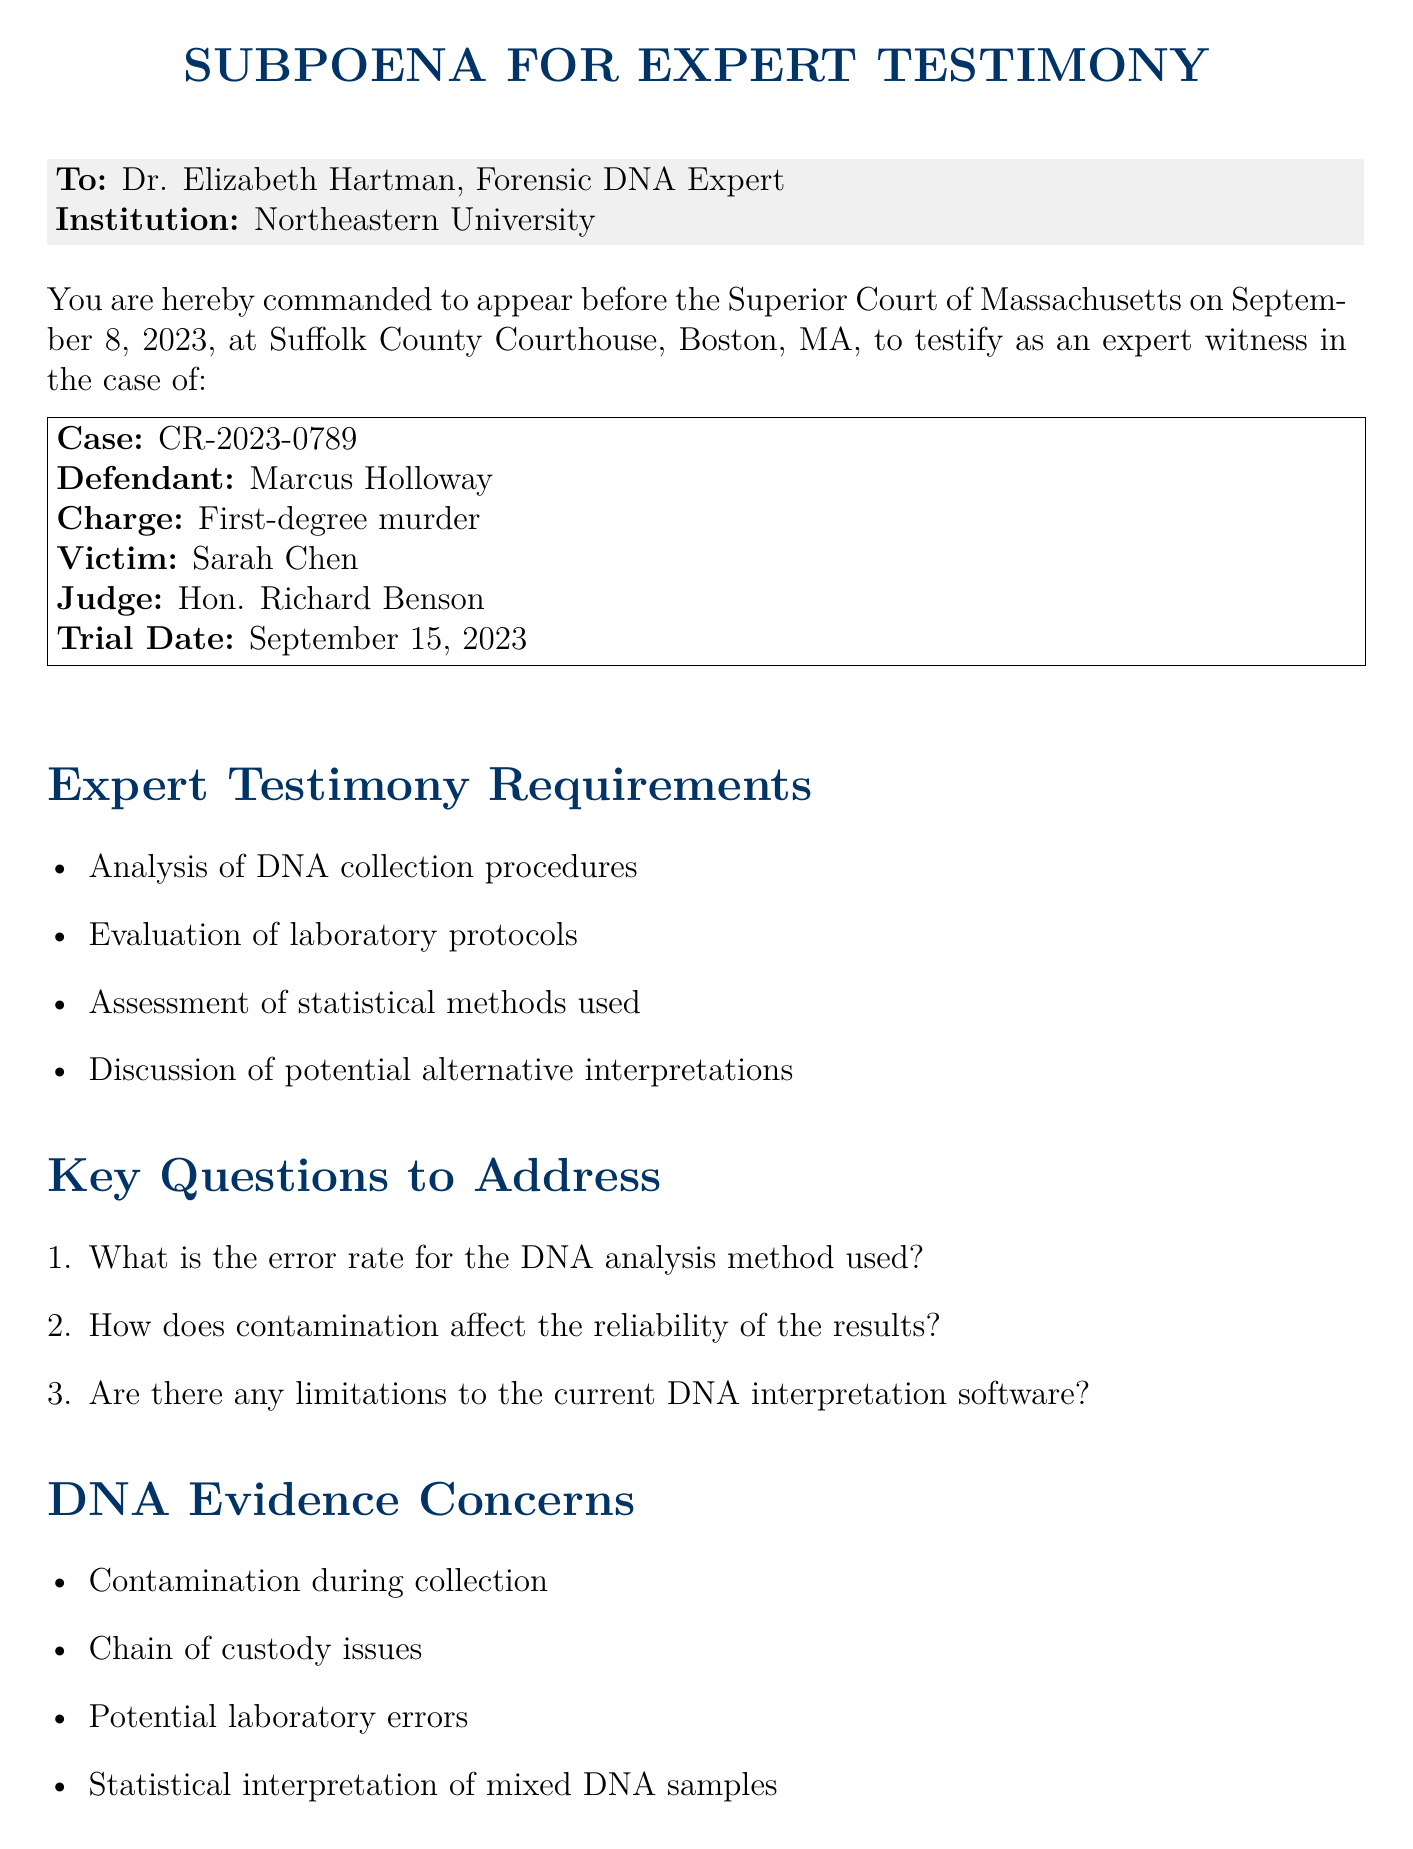What is the name of the forensic DNA expert? The document specifies the expert's name as Dr. Elizabeth Hartman.
Answer: Dr. Elizabeth Hartman What is the case number associated with the subpoena? According to the document, the case number is CR-2023-0789.
Answer: CR-2023-0789 When is the appearance date for the expert testimony? The document states that the appearance date is September 8, 2023.
Answer: September 8, 2023 Who is the defendant in this case? The document identifies the defendant as Marcus Holloway.
Answer: Marcus Holloway What are the required documents listed in the subpoena? The document lists curriculum vitae, a list of prior expert testimony experiences, and any published works relevant to DNA analysis challenges as required documents.
Answer: Curriculum vitae, list of prior expert testimony experiences, and published works What is one of the DNA evidence concerns mentioned? The document mentions "Contamination during collection" as one of the concerns.
Answer: Contamination during collection What is the charge against the defendant? The document provides the charge as first-degree murder.
Answer: First-degree murder Who is the judge presiding over the case? The document specifies that the judge is Hon. Richard Benson.
Answer: Hon. Richard Benson What type of court is conducting the trial? The document indicates that the trial is being held in the Superior Court of Massachusetts.
Answer: Superior Court of Massachusetts 